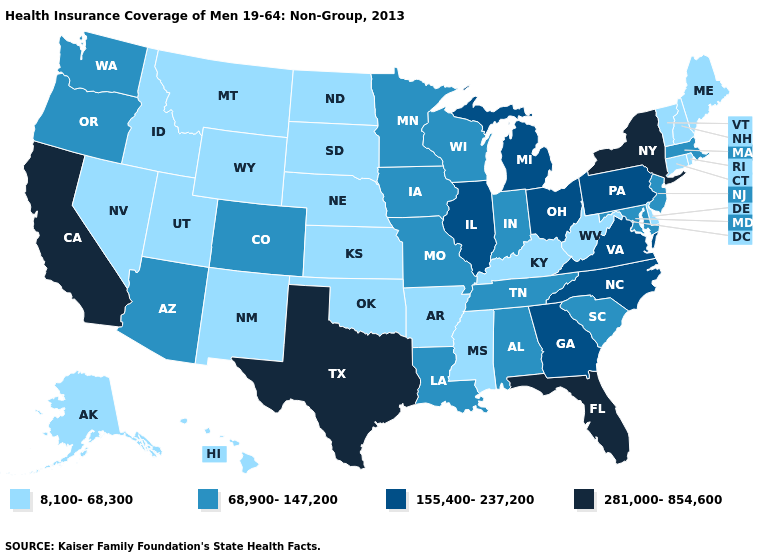What is the highest value in the Northeast ?
Quick response, please. 281,000-854,600. Which states have the lowest value in the USA?
Give a very brief answer. Alaska, Arkansas, Connecticut, Delaware, Hawaii, Idaho, Kansas, Kentucky, Maine, Mississippi, Montana, Nebraska, Nevada, New Hampshire, New Mexico, North Dakota, Oklahoma, Rhode Island, South Dakota, Utah, Vermont, West Virginia, Wyoming. Among the states that border Texas , which have the highest value?
Write a very short answer. Louisiana. Name the states that have a value in the range 281,000-854,600?
Short answer required. California, Florida, New York, Texas. Does the map have missing data?
Be succinct. No. What is the value of Indiana?
Short answer required. 68,900-147,200. Name the states that have a value in the range 155,400-237,200?
Keep it brief. Georgia, Illinois, Michigan, North Carolina, Ohio, Pennsylvania, Virginia. What is the value of Georgia?
Give a very brief answer. 155,400-237,200. Does Texas have the highest value in the USA?
Write a very short answer. Yes. Name the states that have a value in the range 8,100-68,300?
Quick response, please. Alaska, Arkansas, Connecticut, Delaware, Hawaii, Idaho, Kansas, Kentucky, Maine, Mississippi, Montana, Nebraska, Nevada, New Hampshire, New Mexico, North Dakota, Oklahoma, Rhode Island, South Dakota, Utah, Vermont, West Virginia, Wyoming. Name the states that have a value in the range 155,400-237,200?
Write a very short answer. Georgia, Illinois, Michigan, North Carolina, Ohio, Pennsylvania, Virginia. Does the first symbol in the legend represent the smallest category?
Concise answer only. Yes. What is the highest value in the South ?
Quick response, please. 281,000-854,600. How many symbols are there in the legend?
Be succinct. 4. Is the legend a continuous bar?
Short answer required. No. 